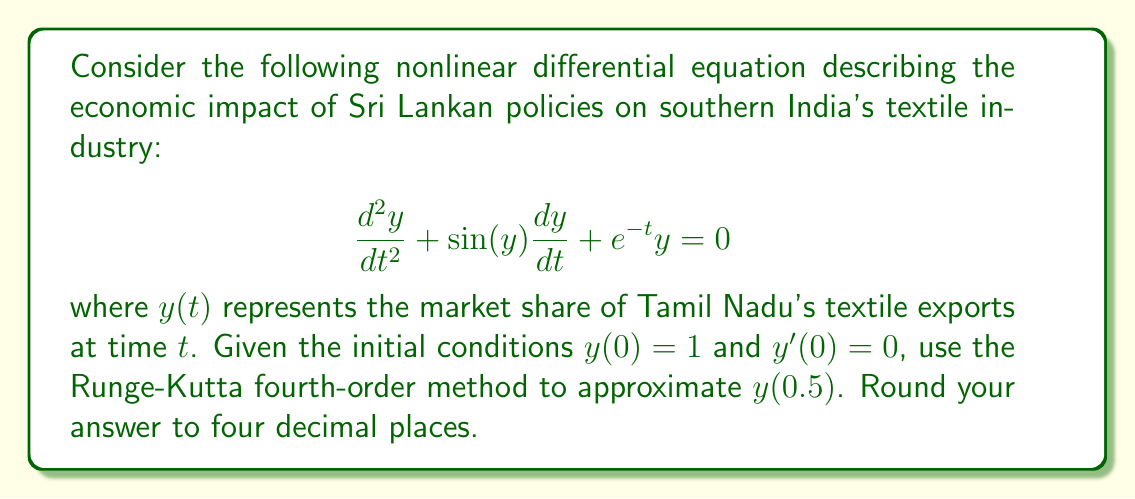Show me your answer to this math problem. To solve this nonlinear differential equation using the Runge-Kutta fourth-order method, we need to convert it into a system of first-order equations:

Let $y_1 = y$ and $y_2 = \frac{dy}{dt}$. Then:

$$\frac{dy_1}{dt} = y_2$$
$$\frac{dy_2}{dt} = -\sin(y_1)y_2 - e^{-t}y_1$$

Now, we apply the Runge-Kutta fourth-order method:

$$k_{1,i} = hf_i(t_n, y_{1,n}, y_{2,n})$$
$$k_{2,i} = hf_i(t_n + \frac{h}{2}, y_{1,n} + \frac{k_{1,1}}{2}, y_{2,n} + \frac{k_{1,2}}{2})$$
$$k_{3,i} = hf_i(t_n + \frac{h}{2}, y_{1,n} + \frac{k_{2,1}}{2}, y_{2,n} + \frac{k_{2,2}}{2})$$
$$k_{4,i} = hf_i(t_n + h, y_{1,n} + k_{3,1}, y_{2,n} + k_{3,2})$$

$$y_{i,n+1} = y_{i,n} + \frac{1}{6}(k_{1,i} + 2k_{2,i} + 2k_{3,i} + k_{4,i})$$

Where $i = 1, 2$ and $h = 0.5$ (the step size).

Step 1: Calculate $k_{1,i}$
$k_{1,1} = h \cdot y_2 = 0.5 \cdot 0 = 0$
$k_{1,2} = h \cdot (-\sin(1) \cdot 0 - e^{-0} \cdot 1) = -0.5$

Step 2: Calculate $k_{2,i}$
$k_{2,1} = h \cdot (0 + \frac{k_{1,2}}{2}) = 0.5 \cdot (-0.25) = -0.125$
$k_{2,2} = h \cdot (-\sin(1 + \frac{k_{1,1}}{2}) \cdot (-0.25) - e^{-0.25} \cdot (1 + \frac{k_{1,1}}{2})) = -0.4403$

Step 3: Calculate $k_{3,i}$
$k_{3,1} = h \cdot (-0.25 + \frac{k_{2,2}}{2}) = 0.5 \cdot (-0.4701) = -0.2351$
$k_{3,2} = h \cdot (-\sin(1 + \frac{k_{2,1}}{2}) \cdot (-0.4701) - e^{-0.25} \cdot (1 + \frac{k_{2,1}}{2})) = -0.3940$

Step 4: Calculate $k_{4,i}$
$k_{4,1} = h \cdot (-0.4701 + k_{3,2}) = 0.5 \cdot (-0.8641) = -0.4321$
$k_{4,2} = h \cdot (-\sin(1 + k_{3,1}) \cdot (-0.8641) - e^{-0.5} \cdot (1 + k_{3,1})) = -0.3125$

Step 5: Calculate $y_{i,1}$
$y_{1,1} = 1 + \frac{1}{6}(0 - 0.25 - 0.4702 - 0.4321) = 0.8087$
$y_{2,1} = 0 + \frac{1}{6}(-0.5 - 0.8806 - 0.7880 - 0.3125) = -0.4135$

Therefore, $y(0.5) \approx 0.8087$.
Answer: 0.8087 